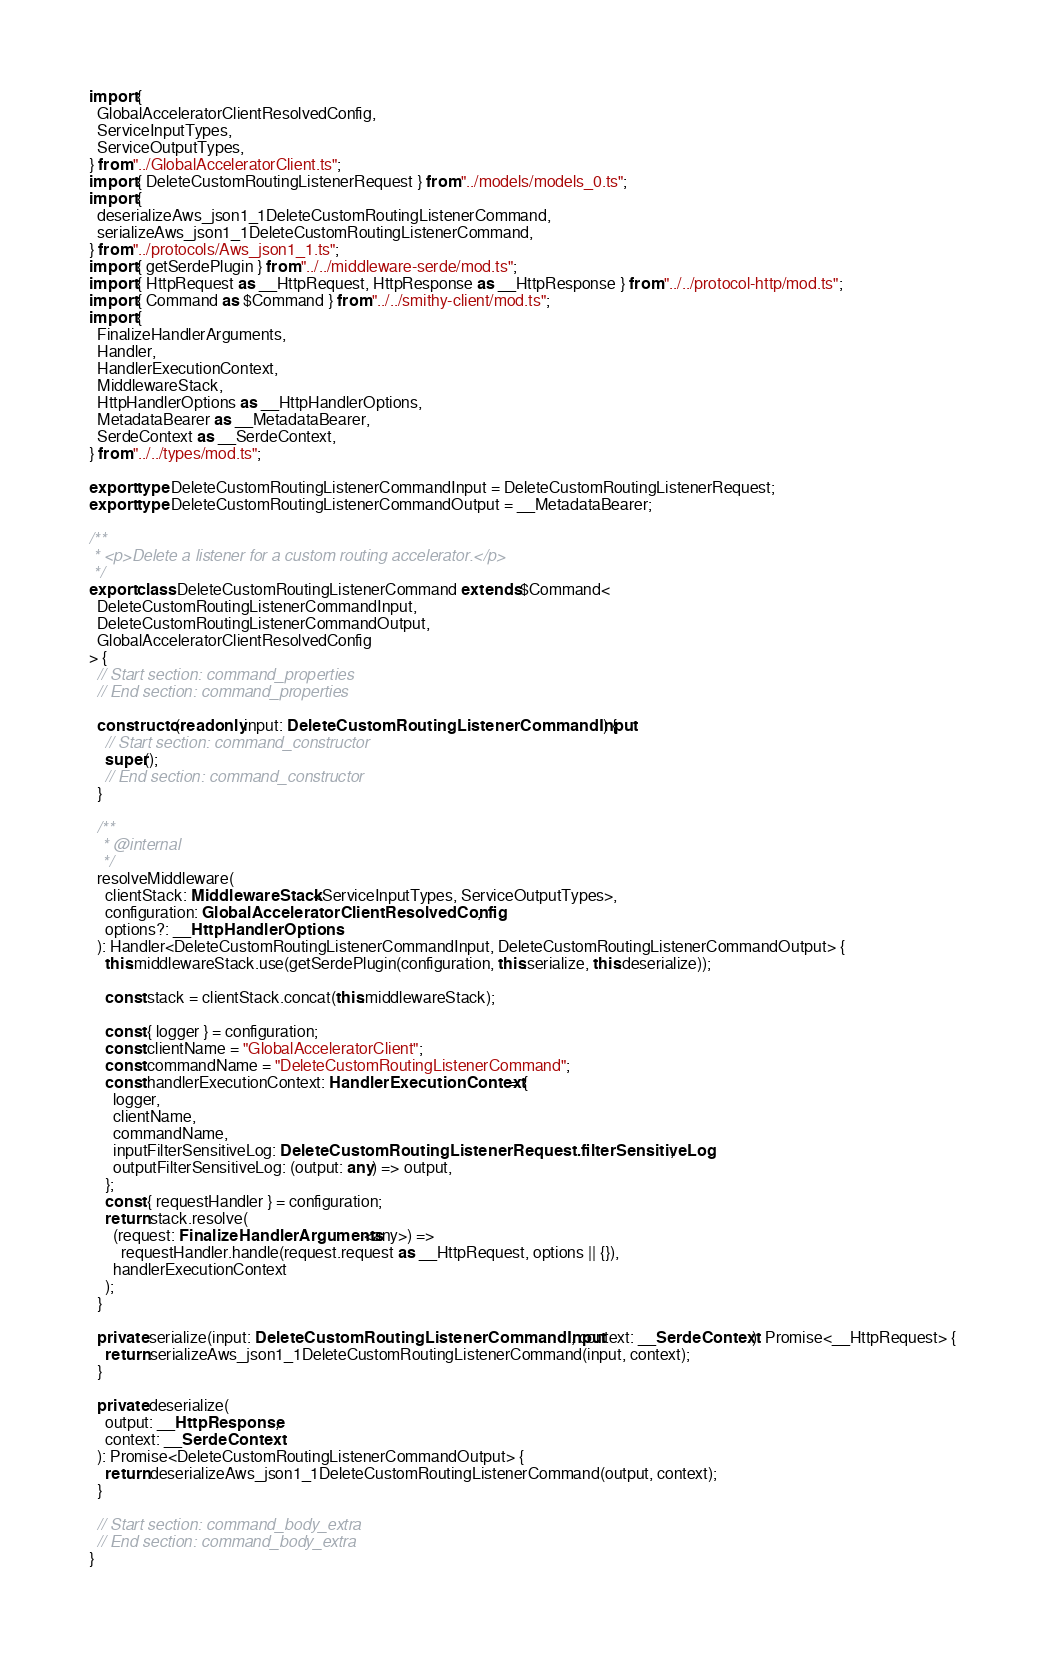<code> <loc_0><loc_0><loc_500><loc_500><_TypeScript_>import {
  GlobalAcceleratorClientResolvedConfig,
  ServiceInputTypes,
  ServiceOutputTypes,
} from "../GlobalAcceleratorClient.ts";
import { DeleteCustomRoutingListenerRequest } from "../models/models_0.ts";
import {
  deserializeAws_json1_1DeleteCustomRoutingListenerCommand,
  serializeAws_json1_1DeleteCustomRoutingListenerCommand,
} from "../protocols/Aws_json1_1.ts";
import { getSerdePlugin } from "../../middleware-serde/mod.ts";
import { HttpRequest as __HttpRequest, HttpResponse as __HttpResponse } from "../../protocol-http/mod.ts";
import { Command as $Command } from "../../smithy-client/mod.ts";
import {
  FinalizeHandlerArguments,
  Handler,
  HandlerExecutionContext,
  MiddlewareStack,
  HttpHandlerOptions as __HttpHandlerOptions,
  MetadataBearer as __MetadataBearer,
  SerdeContext as __SerdeContext,
} from "../../types/mod.ts";

export type DeleteCustomRoutingListenerCommandInput = DeleteCustomRoutingListenerRequest;
export type DeleteCustomRoutingListenerCommandOutput = __MetadataBearer;

/**
 * <p>Delete a listener for a custom routing accelerator.</p>
 */
export class DeleteCustomRoutingListenerCommand extends $Command<
  DeleteCustomRoutingListenerCommandInput,
  DeleteCustomRoutingListenerCommandOutput,
  GlobalAcceleratorClientResolvedConfig
> {
  // Start section: command_properties
  // End section: command_properties

  constructor(readonly input: DeleteCustomRoutingListenerCommandInput) {
    // Start section: command_constructor
    super();
    // End section: command_constructor
  }

  /**
   * @internal
   */
  resolveMiddleware(
    clientStack: MiddlewareStack<ServiceInputTypes, ServiceOutputTypes>,
    configuration: GlobalAcceleratorClientResolvedConfig,
    options?: __HttpHandlerOptions
  ): Handler<DeleteCustomRoutingListenerCommandInput, DeleteCustomRoutingListenerCommandOutput> {
    this.middlewareStack.use(getSerdePlugin(configuration, this.serialize, this.deserialize));

    const stack = clientStack.concat(this.middlewareStack);

    const { logger } = configuration;
    const clientName = "GlobalAcceleratorClient";
    const commandName = "DeleteCustomRoutingListenerCommand";
    const handlerExecutionContext: HandlerExecutionContext = {
      logger,
      clientName,
      commandName,
      inputFilterSensitiveLog: DeleteCustomRoutingListenerRequest.filterSensitiveLog,
      outputFilterSensitiveLog: (output: any) => output,
    };
    const { requestHandler } = configuration;
    return stack.resolve(
      (request: FinalizeHandlerArguments<any>) =>
        requestHandler.handle(request.request as __HttpRequest, options || {}),
      handlerExecutionContext
    );
  }

  private serialize(input: DeleteCustomRoutingListenerCommandInput, context: __SerdeContext): Promise<__HttpRequest> {
    return serializeAws_json1_1DeleteCustomRoutingListenerCommand(input, context);
  }

  private deserialize(
    output: __HttpResponse,
    context: __SerdeContext
  ): Promise<DeleteCustomRoutingListenerCommandOutput> {
    return deserializeAws_json1_1DeleteCustomRoutingListenerCommand(output, context);
  }

  // Start section: command_body_extra
  // End section: command_body_extra
}
</code> 